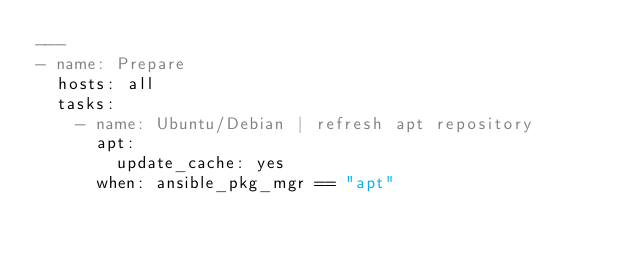Convert code to text. <code><loc_0><loc_0><loc_500><loc_500><_YAML_>---
- name: Prepare
  hosts: all
  tasks:
    - name: Ubuntu/Debian | refresh apt repository
      apt:
        update_cache: yes
      when: ansible_pkg_mgr == "apt"
</code> 